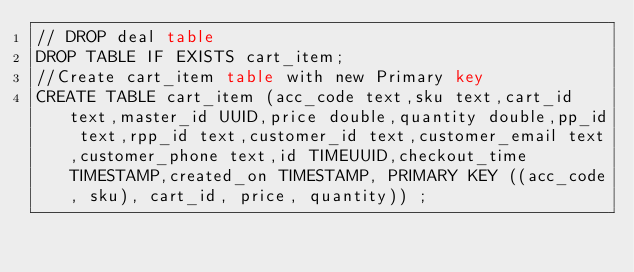Convert code to text. <code><loc_0><loc_0><loc_500><loc_500><_SQL_>// DROP deal table
DROP TABLE IF EXISTS cart_item;
//Create cart_item table with new Primary key
CREATE TABLE cart_item (acc_code text,sku text,cart_id text,master_id UUID,price double,quantity double,pp_id text,rpp_id text,customer_id text,customer_email text,customer_phone text,id TIMEUUID,checkout_time TIMESTAMP,created_on TIMESTAMP, PRIMARY KEY ((acc_code, sku), cart_id, price, quantity)) ;</code> 